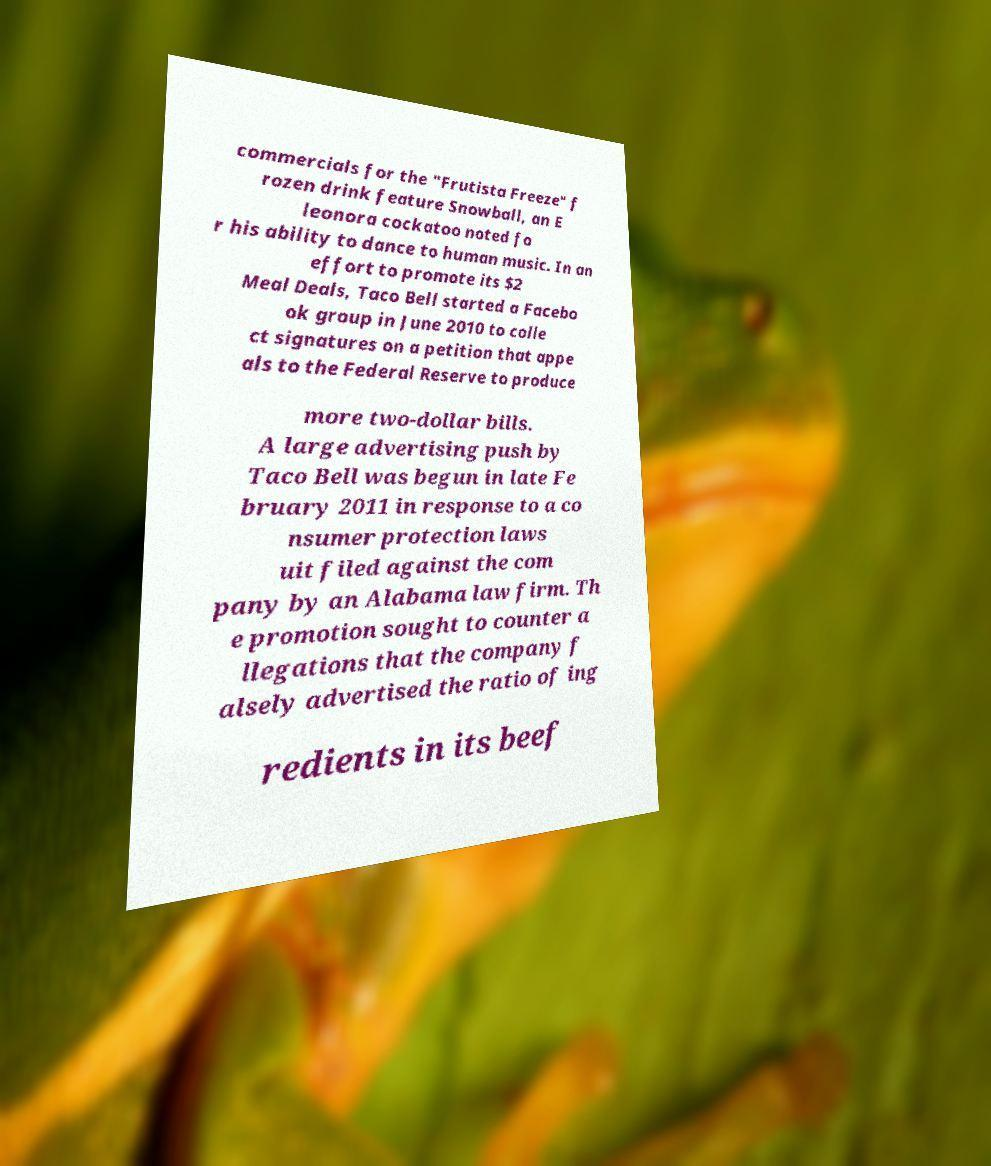I need the written content from this picture converted into text. Can you do that? commercials for the "Frutista Freeze" f rozen drink feature Snowball, an E leonora cockatoo noted fo r his ability to dance to human music. In an effort to promote its $2 Meal Deals, Taco Bell started a Facebo ok group in June 2010 to colle ct signatures on a petition that appe als to the Federal Reserve to produce more two-dollar bills. A large advertising push by Taco Bell was begun in late Fe bruary 2011 in response to a co nsumer protection laws uit filed against the com pany by an Alabama law firm. Th e promotion sought to counter a llegations that the company f alsely advertised the ratio of ing redients in its beef 